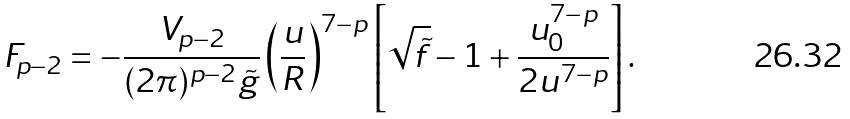<formula> <loc_0><loc_0><loc_500><loc_500>F _ { p - 2 } = - \frac { V _ { p - 2 } } { ( 2 \pi ) ^ { p - 2 } \tilde { g } } \left ( \frac { u } { R } \right ) ^ { 7 - p } \left [ \sqrt { \tilde { f } } - 1 + \frac { u _ { 0 } ^ { 7 - p } } { 2 u ^ { 7 - p } } \right ] .</formula> 